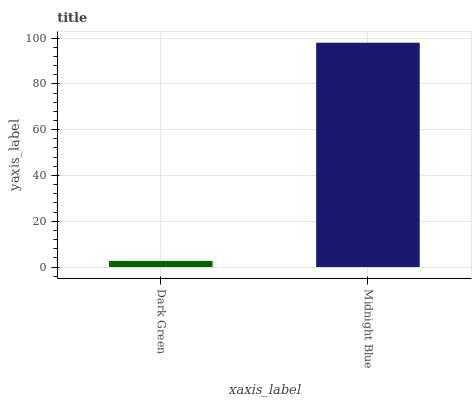Is Dark Green the minimum?
Answer yes or no. Yes. Is Midnight Blue the maximum?
Answer yes or no. Yes. Is Midnight Blue the minimum?
Answer yes or no. No. Is Midnight Blue greater than Dark Green?
Answer yes or no. Yes. Is Dark Green less than Midnight Blue?
Answer yes or no. Yes. Is Dark Green greater than Midnight Blue?
Answer yes or no. No. Is Midnight Blue less than Dark Green?
Answer yes or no. No. Is Midnight Blue the high median?
Answer yes or no. Yes. Is Dark Green the low median?
Answer yes or no. Yes. Is Dark Green the high median?
Answer yes or no. No. Is Midnight Blue the low median?
Answer yes or no. No. 